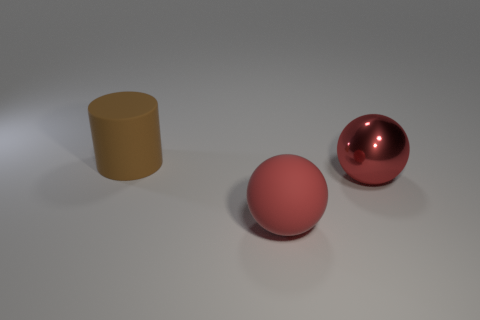Add 3 spheres. How many objects exist? 6 Subtract all balls. How many objects are left? 1 Subtract 0 yellow spheres. How many objects are left? 3 Subtract all large gray shiny cylinders. Subtract all shiny spheres. How many objects are left? 2 Add 2 large cylinders. How many large cylinders are left? 3 Add 1 small cyan things. How many small cyan things exist? 1 